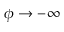Convert formula to latex. <formula><loc_0><loc_0><loc_500><loc_500>\phi \to - \infty</formula> 